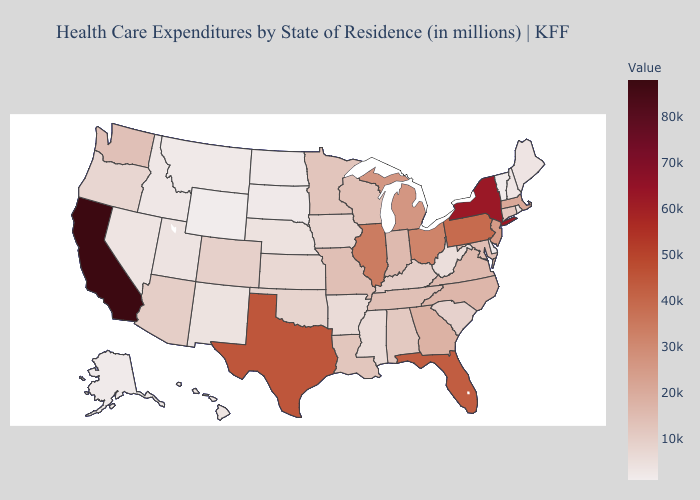Among the states that border Arkansas , does Mississippi have the lowest value?
Keep it brief. Yes. Does California have the highest value in the USA?
Keep it brief. Yes. Which states have the highest value in the USA?
Write a very short answer. California. Which states hav the highest value in the South?
Write a very short answer. Texas. 